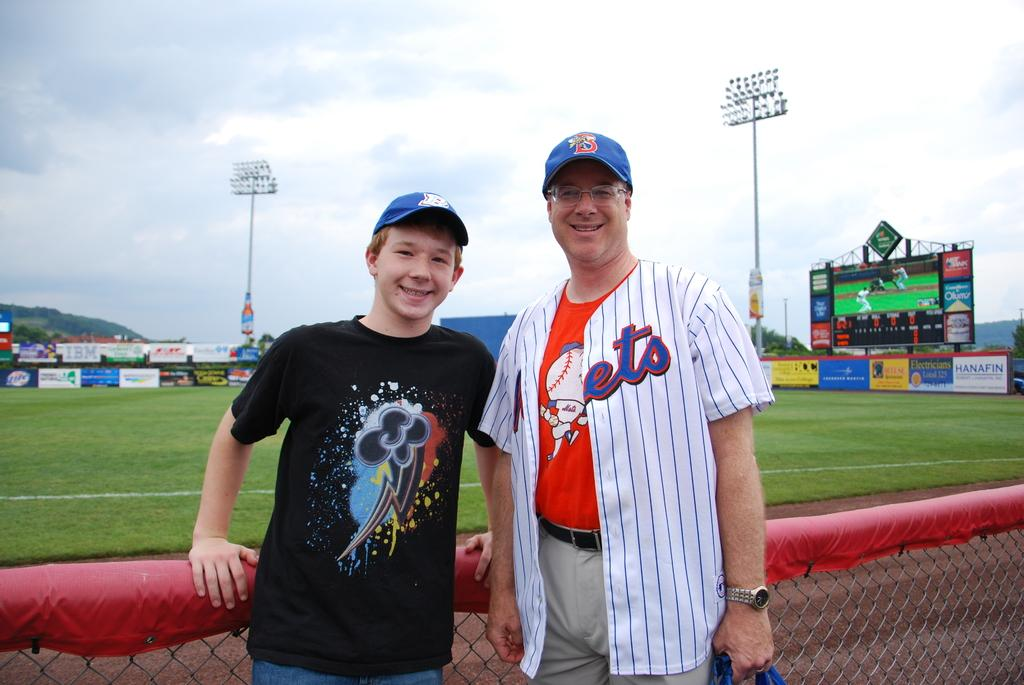<image>
Present a compact description of the photo's key features. A man in a Mets shirt and a boy standing outside of a baseball diamond. 